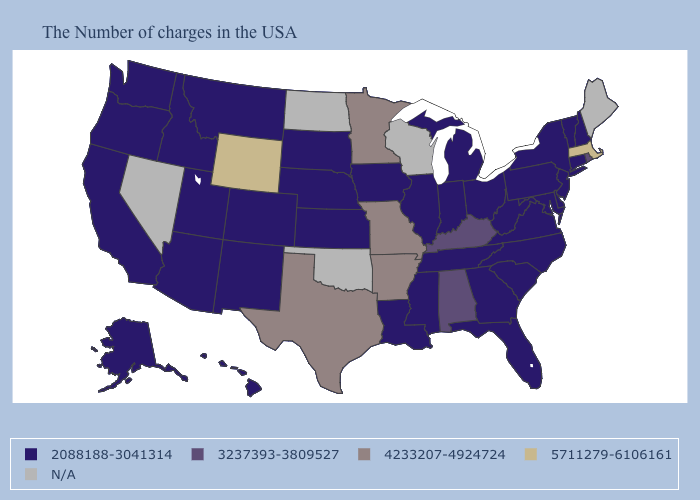Name the states that have a value in the range 4233207-4924724?
Answer briefly. Missouri, Arkansas, Minnesota, Texas. Among the states that border Vermont , does New York have the lowest value?
Short answer required. Yes. Which states have the lowest value in the USA?
Quick response, please. New Hampshire, Vermont, Connecticut, New York, New Jersey, Delaware, Maryland, Pennsylvania, Virginia, North Carolina, South Carolina, West Virginia, Ohio, Florida, Georgia, Michigan, Indiana, Tennessee, Illinois, Mississippi, Louisiana, Iowa, Kansas, Nebraska, South Dakota, Colorado, New Mexico, Utah, Montana, Arizona, Idaho, California, Washington, Oregon, Alaska, Hawaii. What is the value of Alabama?
Give a very brief answer. 3237393-3809527. Which states have the highest value in the USA?
Give a very brief answer. Massachusetts, Wyoming. What is the value of Pennsylvania?
Quick response, please. 2088188-3041314. Among the states that border Texas , does Arkansas have the lowest value?
Be succinct. No. Which states hav the highest value in the MidWest?
Be succinct. Missouri, Minnesota. What is the highest value in states that border Arizona?
Concise answer only. 2088188-3041314. Which states have the highest value in the USA?
Give a very brief answer. Massachusetts, Wyoming. How many symbols are there in the legend?
Write a very short answer. 5. Name the states that have a value in the range 3237393-3809527?
Give a very brief answer. Rhode Island, Kentucky, Alabama. Among the states that border California , which have the highest value?
Short answer required. Arizona, Oregon. 